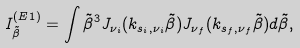<formula> <loc_0><loc_0><loc_500><loc_500>I _ { \tilde { \beta } } ^ { ( E 1 ) } = \int \tilde { \beta } ^ { 3 } J _ { \nu _ { i } } ( k _ { s _ { i } , \nu _ { i } } \tilde { \beta } ) J _ { \nu _ { f } } ( k _ { s _ { f } , \nu _ { f } } \tilde { \beta } ) d \tilde { \beta } ,</formula> 